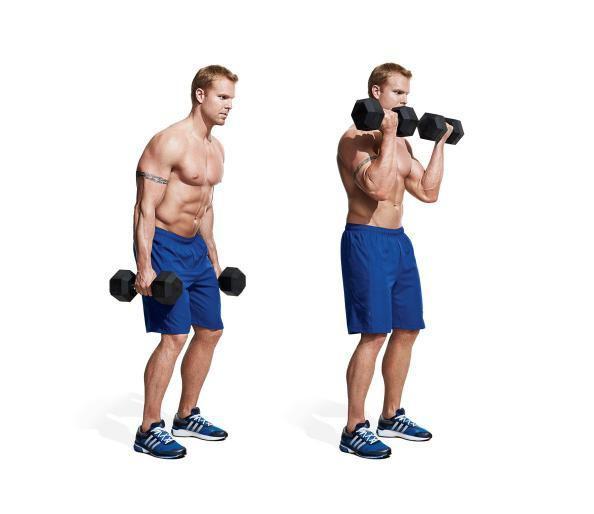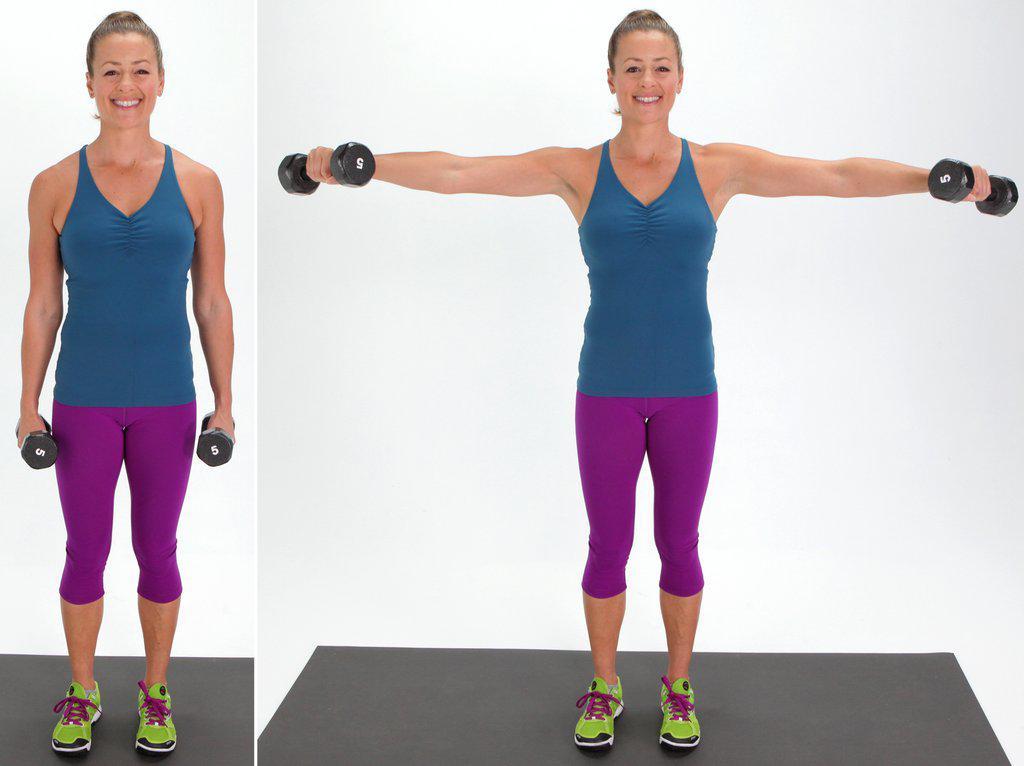The first image is the image on the left, the second image is the image on the right. Assess this claim about the two images: "A man wearing blue short is holding dumbells". Correct or not? Answer yes or no. Yes. 